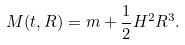<formula> <loc_0><loc_0><loc_500><loc_500>M ( t , R ) = m + \frac { 1 } { 2 } H ^ { 2 } R ^ { 3 } .</formula> 